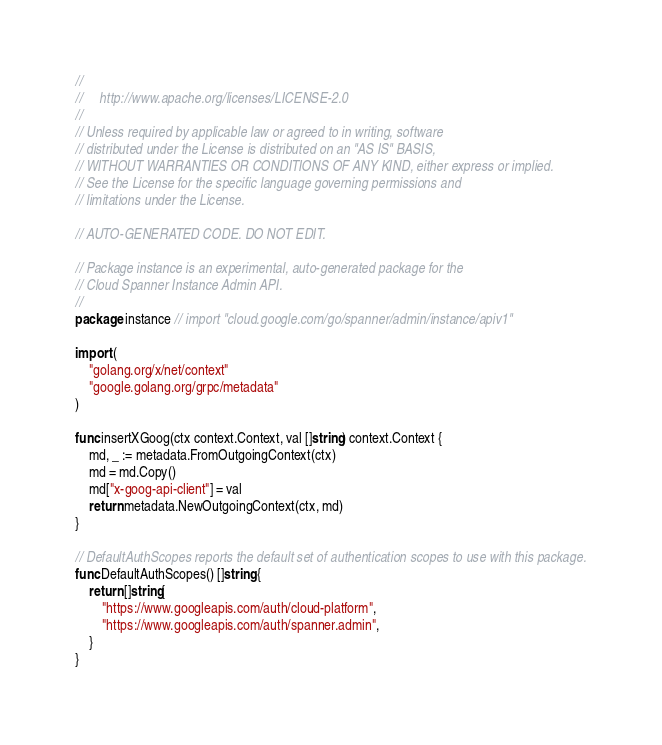<code> <loc_0><loc_0><loc_500><loc_500><_Go_>//
//     http://www.apache.org/licenses/LICENSE-2.0
//
// Unless required by applicable law or agreed to in writing, software
// distributed under the License is distributed on an "AS IS" BASIS,
// WITHOUT WARRANTIES OR CONDITIONS OF ANY KIND, either express or implied.
// See the License for the specific language governing permissions and
// limitations under the License.

// AUTO-GENERATED CODE. DO NOT EDIT.

// Package instance is an experimental, auto-generated package for the
// Cloud Spanner Instance Admin API.
//
package instance // import "cloud.google.com/go/spanner/admin/instance/apiv1"

import (
	"golang.org/x/net/context"
	"google.golang.org/grpc/metadata"
)

func insertXGoog(ctx context.Context, val []string) context.Context {
	md, _ := metadata.FromOutgoingContext(ctx)
	md = md.Copy()
	md["x-goog-api-client"] = val
	return metadata.NewOutgoingContext(ctx, md)
}

// DefaultAuthScopes reports the default set of authentication scopes to use with this package.
func DefaultAuthScopes() []string {
	return []string{
		"https://www.googleapis.com/auth/cloud-platform",
		"https://www.googleapis.com/auth/spanner.admin",
	}
}
</code> 